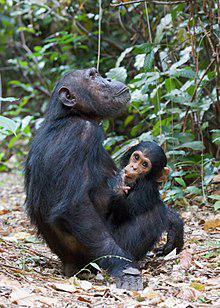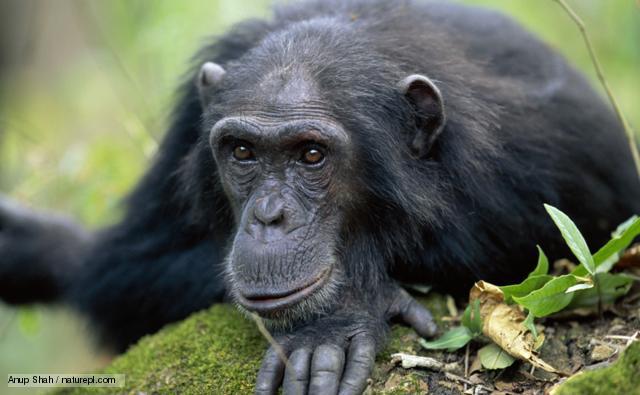The first image is the image on the left, the second image is the image on the right. For the images displayed, is the sentence "The left photo contains a single chimp." factually correct? Answer yes or no. No. The first image is the image on the left, the second image is the image on the right. For the images displayed, is the sentence "The image on the right shows a single animal gazing into the distance." factually correct? Answer yes or no. Yes. 